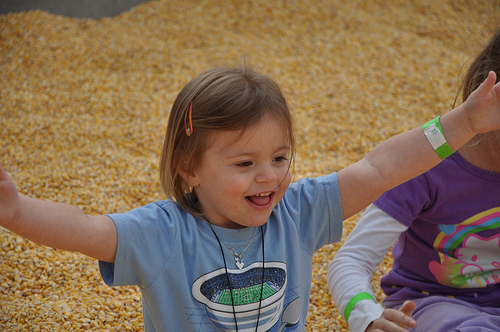<image>
Is there a baby on the corn? Yes. Looking at the image, I can see the baby is positioned on top of the corn, with the corn providing support. 